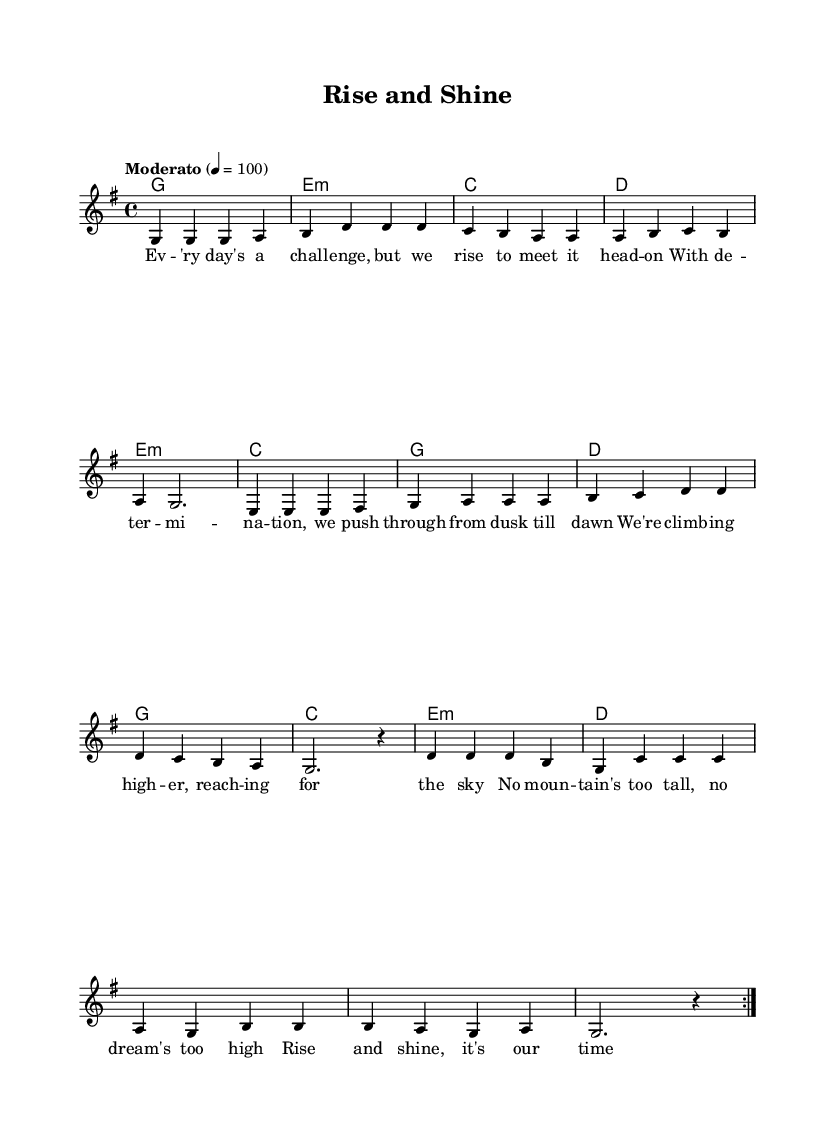What is the key signature of this music? The key signature is G major, indicated by the presence of one sharp (F#) in the music notation. This can be confirmed by looking at the key signature symbol at the beginning of the staff.
Answer: G major What is the time signature used in this piece? The time signature is 4/4, which means there are four beats in each measure and the quarter note gets one beat. This is represented at the beginning of the sheet music.
Answer: 4/4 What tempo marking is indicated for this piece? The tempo marking is "Moderato," with a metronome marking of 100 beats per minute. This can be found written at the beginning of the score.
Answer: Moderato How many measures are in the chorus section? The chorus section contains 4 measures as indicated in the music, which can be counted from the distinct groupings and the measure lines drawn in the music sheet.
Answer: 4 What is the first lyric phrase of the verse? The first lyric phrase is "Ev'ry day's a challenge, but we rise to meet it head on." This can be identified directly from the verses aligned under the melody notes.
Answer: Ev'ry day's a challenge, but we rise to meet it head on Which chords are used in the pre-chorus? The chords used in the pre-chorus are E minor, C major, G major, and D major. These chords are written above the melody for that section and follow a clear harmonic progression.
Answer: E minor, C, G, D How does the melody start for the first measure? The melody starts with the note G in the first measure, which is notated clearly at the beginning of the staff.
Answer: G 